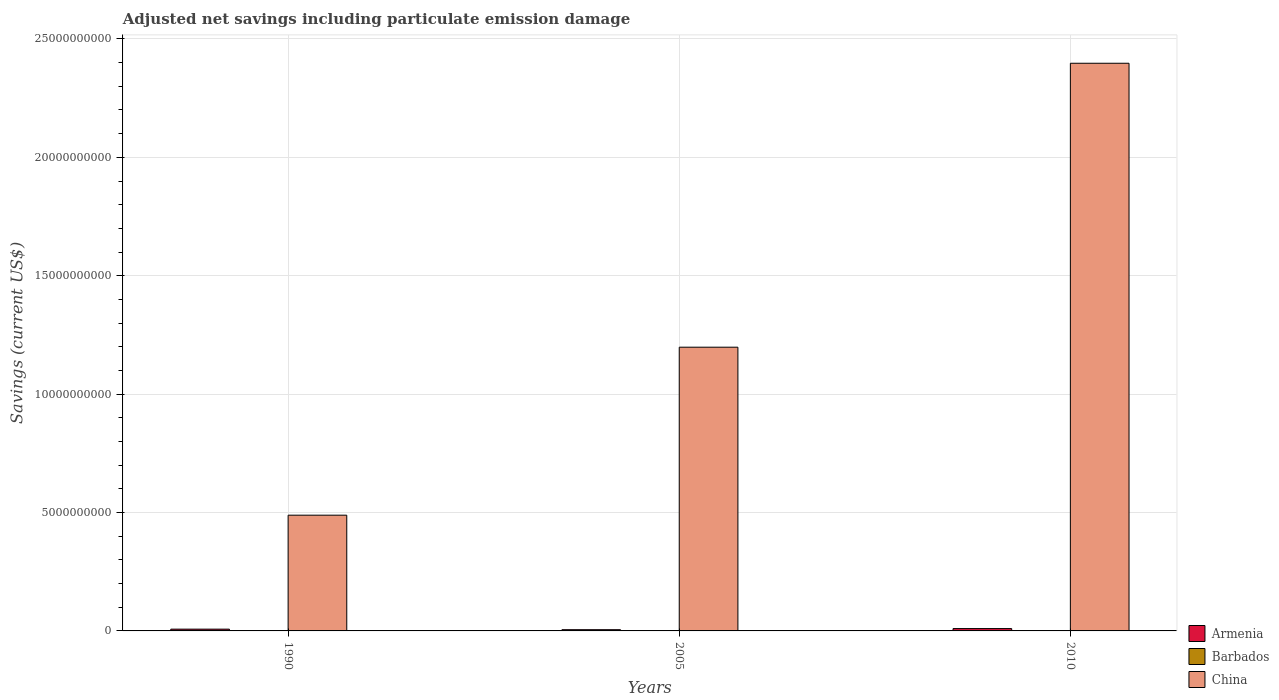How many different coloured bars are there?
Offer a very short reply. 3. How many groups of bars are there?
Offer a terse response. 3. Are the number of bars per tick equal to the number of legend labels?
Provide a succinct answer. Yes. How many bars are there on the 1st tick from the left?
Provide a succinct answer. 3. What is the label of the 1st group of bars from the left?
Ensure brevity in your answer.  1990. In how many cases, is the number of bars for a given year not equal to the number of legend labels?
Provide a short and direct response. 0. What is the net savings in Barbados in 2010?
Offer a terse response. 1.72e+07. Across all years, what is the maximum net savings in Barbados?
Your answer should be very brief. 1.72e+07. Across all years, what is the minimum net savings in Armenia?
Offer a very short reply. 5.19e+07. In which year was the net savings in China maximum?
Your answer should be compact. 2010. In which year was the net savings in Armenia minimum?
Make the answer very short. 2005. What is the total net savings in Armenia in the graph?
Provide a succinct answer. 2.26e+08. What is the difference between the net savings in Armenia in 1990 and that in 2010?
Provide a short and direct response. -2.41e+07. What is the difference between the net savings in Armenia in 2005 and the net savings in China in 1990?
Offer a terse response. -4.84e+09. What is the average net savings in Barbados per year?
Make the answer very short. 1.41e+07. In the year 1990, what is the difference between the net savings in Armenia and net savings in Barbados?
Your answer should be very brief. 6.38e+07. What is the ratio of the net savings in Armenia in 2005 to that in 2010?
Your answer should be compact. 0.52. Is the difference between the net savings in Armenia in 1990 and 2010 greater than the difference between the net savings in Barbados in 1990 and 2010?
Your response must be concise. No. What is the difference between the highest and the second highest net savings in Armenia?
Offer a terse response. 2.41e+07. What is the difference between the highest and the lowest net savings in China?
Provide a succinct answer. 1.91e+1. In how many years, is the net savings in Barbados greater than the average net savings in Barbados taken over all years?
Keep it short and to the point. 1. What does the 2nd bar from the left in 1990 represents?
Offer a very short reply. Barbados. What does the 2nd bar from the right in 2010 represents?
Keep it short and to the point. Barbados. How many bars are there?
Your answer should be very brief. 9. How many years are there in the graph?
Provide a succinct answer. 3. What is the difference between two consecutive major ticks on the Y-axis?
Your answer should be compact. 5.00e+09. Does the graph contain any zero values?
Your answer should be compact. No. Where does the legend appear in the graph?
Your answer should be very brief. Bottom right. How many legend labels are there?
Offer a terse response. 3. How are the legend labels stacked?
Offer a terse response. Vertical. What is the title of the graph?
Make the answer very short. Adjusted net savings including particulate emission damage. Does "Other small states" appear as one of the legend labels in the graph?
Keep it short and to the point. No. What is the label or title of the X-axis?
Your answer should be very brief. Years. What is the label or title of the Y-axis?
Keep it short and to the point. Savings (current US$). What is the Savings (current US$) of Armenia in 1990?
Provide a short and direct response. 7.50e+07. What is the Savings (current US$) of Barbados in 1990?
Make the answer very short. 1.12e+07. What is the Savings (current US$) in China in 1990?
Provide a succinct answer. 4.89e+09. What is the Savings (current US$) of Armenia in 2005?
Ensure brevity in your answer.  5.19e+07. What is the Savings (current US$) in Barbados in 2005?
Provide a succinct answer. 1.38e+07. What is the Savings (current US$) of China in 2005?
Your response must be concise. 1.20e+1. What is the Savings (current US$) of Armenia in 2010?
Provide a succinct answer. 9.91e+07. What is the Savings (current US$) in Barbados in 2010?
Provide a succinct answer. 1.72e+07. What is the Savings (current US$) in China in 2010?
Give a very brief answer. 2.40e+1. Across all years, what is the maximum Savings (current US$) in Armenia?
Your answer should be very brief. 9.91e+07. Across all years, what is the maximum Savings (current US$) in Barbados?
Offer a terse response. 1.72e+07. Across all years, what is the maximum Savings (current US$) of China?
Keep it short and to the point. 2.40e+1. Across all years, what is the minimum Savings (current US$) in Armenia?
Your answer should be compact. 5.19e+07. Across all years, what is the minimum Savings (current US$) of Barbados?
Provide a short and direct response. 1.12e+07. Across all years, what is the minimum Savings (current US$) in China?
Your answer should be very brief. 4.89e+09. What is the total Savings (current US$) in Armenia in the graph?
Make the answer very short. 2.26e+08. What is the total Savings (current US$) of Barbados in the graph?
Ensure brevity in your answer.  4.23e+07. What is the total Savings (current US$) in China in the graph?
Your response must be concise. 4.08e+1. What is the difference between the Savings (current US$) in Armenia in 1990 and that in 2005?
Provide a short and direct response. 2.32e+07. What is the difference between the Savings (current US$) in Barbados in 1990 and that in 2005?
Your answer should be very brief. -2.60e+06. What is the difference between the Savings (current US$) in China in 1990 and that in 2005?
Give a very brief answer. -7.09e+09. What is the difference between the Savings (current US$) in Armenia in 1990 and that in 2010?
Your answer should be very brief. -2.41e+07. What is the difference between the Savings (current US$) of Barbados in 1990 and that in 2010?
Offer a very short reply. -6.00e+06. What is the difference between the Savings (current US$) of China in 1990 and that in 2010?
Offer a terse response. -1.91e+1. What is the difference between the Savings (current US$) in Armenia in 2005 and that in 2010?
Your response must be concise. -4.72e+07. What is the difference between the Savings (current US$) in Barbados in 2005 and that in 2010?
Offer a terse response. -3.40e+06. What is the difference between the Savings (current US$) of China in 2005 and that in 2010?
Your answer should be compact. -1.20e+1. What is the difference between the Savings (current US$) in Armenia in 1990 and the Savings (current US$) in Barbados in 2005?
Your answer should be very brief. 6.12e+07. What is the difference between the Savings (current US$) of Armenia in 1990 and the Savings (current US$) of China in 2005?
Offer a very short reply. -1.19e+1. What is the difference between the Savings (current US$) in Barbados in 1990 and the Savings (current US$) in China in 2005?
Provide a short and direct response. -1.20e+1. What is the difference between the Savings (current US$) of Armenia in 1990 and the Savings (current US$) of Barbados in 2010?
Keep it short and to the point. 5.78e+07. What is the difference between the Savings (current US$) of Armenia in 1990 and the Savings (current US$) of China in 2010?
Ensure brevity in your answer.  -2.39e+1. What is the difference between the Savings (current US$) of Barbados in 1990 and the Savings (current US$) of China in 2010?
Your answer should be very brief. -2.40e+1. What is the difference between the Savings (current US$) in Armenia in 2005 and the Savings (current US$) in Barbados in 2010?
Your answer should be very brief. 3.46e+07. What is the difference between the Savings (current US$) of Armenia in 2005 and the Savings (current US$) of China in 2010?
Offer a terse response. -2.39e+1. What is the difference between the Savings (current US$) in Barbados in 2005 and the Savings (current US$) in China in 2010?
Your answer should be very brief. -2.40e+1. What is the average Savings (current US$) of Armenia per year?
Offer a very short reply. 7.53e+07. What is the average Savings (current US$) of Barbados per year?
Provide a short and direct response. 1.41e+07. What is the average Savings (current US$) of China per year?
Your response must be concise. 1.36e+1. In the year 1990, what is the difference between the Savings (current US$) in Armenia and Savings (current US$) in Barbados?
Provide a succinct answer. 6.38e+07. In the year 1990, what is the difference between the Savings (current US$) in Armenia and Savings (current US$) in China?
Keep it short and to the point. -4.81e+09. In the year 1990, what is the difference between the Savings (current US$) in Barbados and Savings (current US$) in China?
Offer a very short reply. -4.88e+09. In the year 2005, what is the difference between the Savings (current US$) of Armenia and Savings (current US$) of Barbados?
Give a very brief answer. 3.80e+07. In the year 2005, what is the difference between the Savings (current US$) in Armenia and Savings (current US$) in China?
Ensure brevity in your answer.  -1.19e+1. In the year 2005, what is the difference between the Savings (current US$) of Barbados and Savings (current US$) of China?
Your answer should be compact. -1.20e+1. In the year 2010, what is the difference between the Savings (current US$) of Armenia and Savings (current US$) of Barbados?
Provide a succinct answer. 8.19e+07. In the year 2010, what is the difference between the Savings (current US$) of Armenia and Savings (current US$) of China?
Offer a terse response. -2.39e+1. In the year 2010, what is the difference between the Savings (current US$) of Barbados and Savings (current US$) of China?
Give a very brief answer. -2.40e+1. What is the ratio of the Savings (current US$) of Armenia in 1990 to that in 2005?
Offer a terse response. 1.45. What is the ratio of the Savings (current US$) of Barbados in 1990 to that in 2005?
Ensure brevity in your answer.  0.81. What is the ratio of the Savings (current US$) of China in 1990 to that in 2005?
Make the answer very short. 0.41. What is the ratio of the Savings (current US$) in Armenia in 1990 to that in 2010?
Keep it short and to the point. 0.76. What is the ratio of the Savings (current US$) in Barbados in 1990 to that in 2010?
Offer a very short reply. 0.65. What is the ratio of the Savings (current US$) of China in 1990 to that in 2010?
Your response must be concise. 0.2. What is the ratio of the Savings (current US$) in Armenia in 2005 to that in 2010?
Ensure brevity in your answer.  0.52. What is the ratio of the Savings (current US$) of Barbados in 2005 to that in 2010?
Offer a terse response. 0.8. What is the ratio of the Savings (current US$) of China in 2005 to that in 2010?
Your answer should be very brief. 0.5. What is the difference between the highest and the second highest Savings (current US$) of Armenia?
Give a very brief answer. 2.41e+07. What is the difference between the highest and the second highest Savings (current US$) in Barbados?
Ensure brevity in your answer.  3.40e+06. What is the difference between the highest and the second highest Savings (current US$) in China?
Offer a very short reply. 1.20e+1. What is the difference between the highest and the lowest Savings (current US$) of Armenia?
Your response must be concise. 4.72e+07. What is the difference between the highest and the lowest Savings (current US$) of Barbados?
Keep it short and to the point. 6.00e+06. What is the difference between the highest and the lowest Savings (current US$) of China?
Provide a short and direct response. 1.91e+1. 